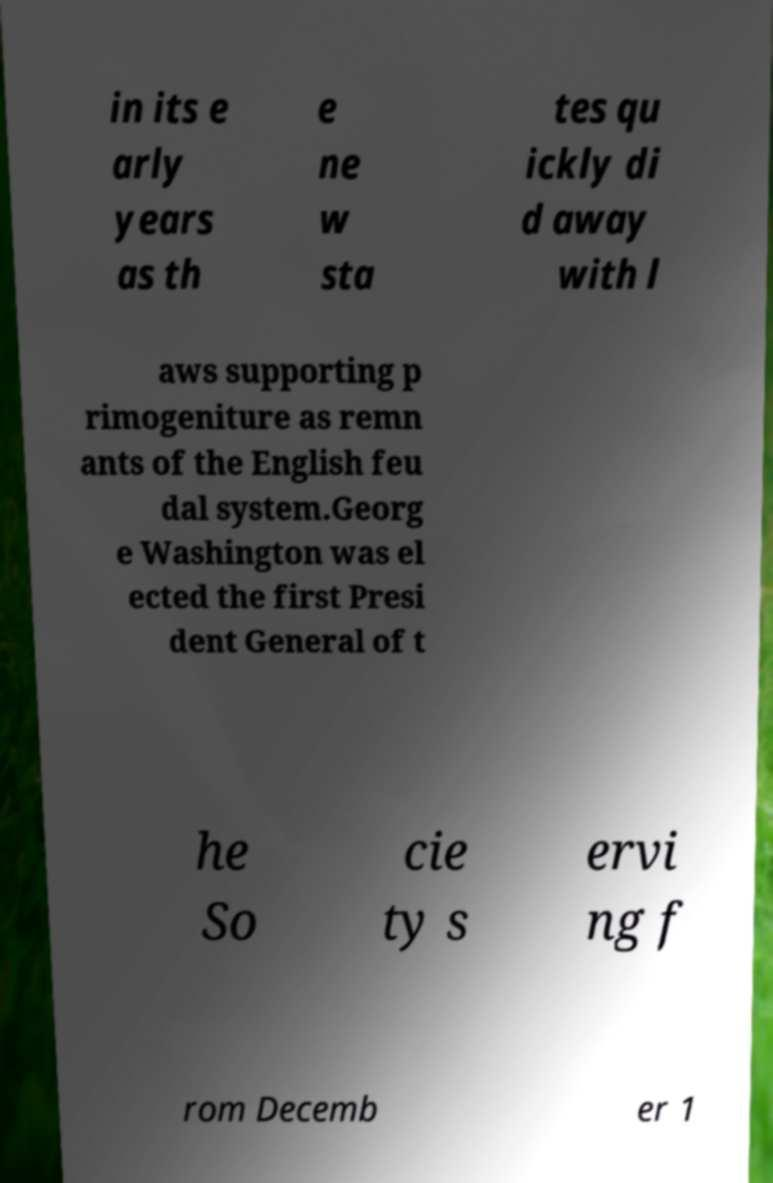There's text embedded in this image that I need extracted. Can you transcribe it verbatim? in its e arly years as th e ne w sta tes qu ickly di d away with l aws supporting p rimogeniture as remn ants of the English feu dal system.Georg e Washington was el ected the first Presi dent General of t he So cie ty s ervi ng f rom Decemb er 1 